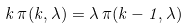<formula> <loc_0><loc_0><loc_500><loc_500>k \, \pi ( k , \lambda ) = \lambda \, \pi ( k - 1 , \lambda )</formula> 